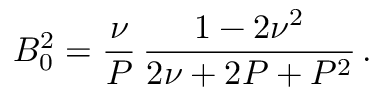<formula> <loc_0><loc_0><loc_500><loc_500>B _ { 0 } ^ { 2 } = \frac { \nu } { P } \, \frac { 1 - 2 \nu ^ { 2 } } { 2 \nu + 2 P + P ^ { 2 } } \, .</formula> 